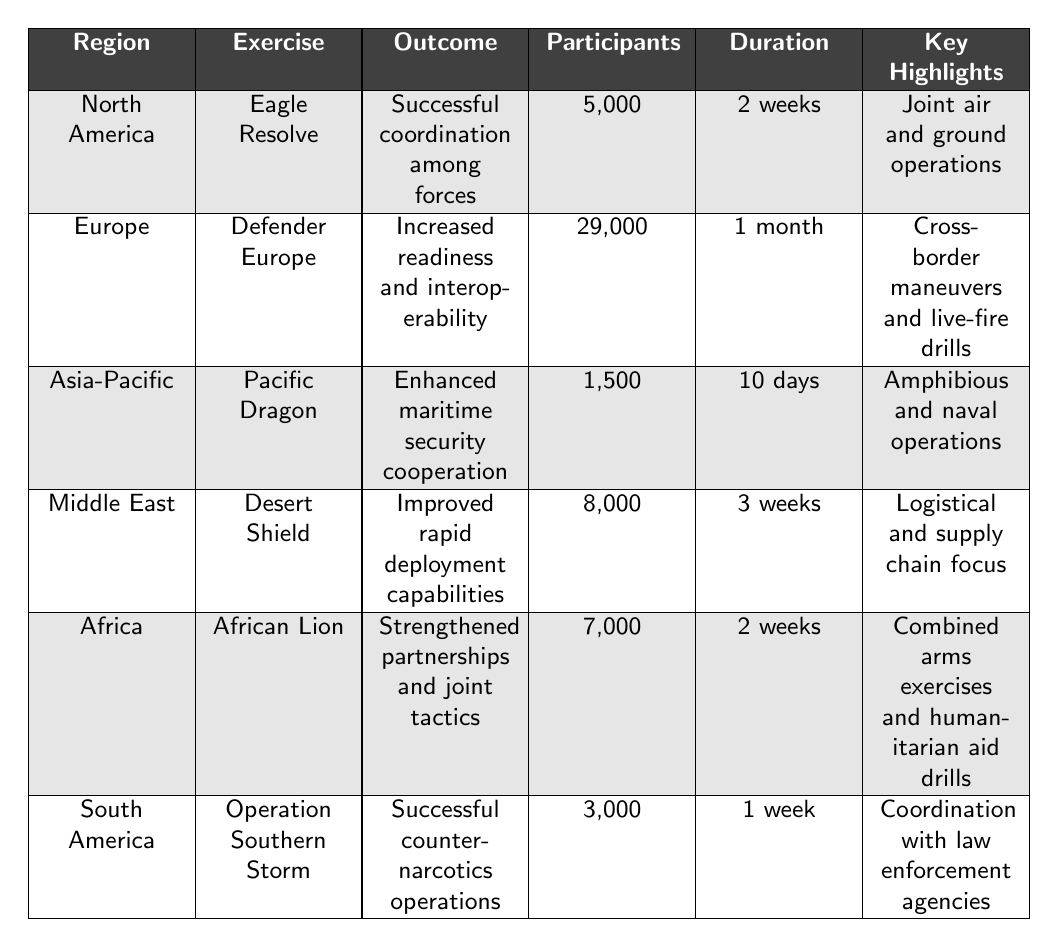What is the region with the highest number of participants in tactical exercises? By examining the 'Participants' column, I see that 'Defender Europe' in Europe has 29,000 participants, which is higher than any other entry.
Answer: Europe Which exercise took place in the Asia-Pacific region? The table lists 'Pacific Dragon' as the exercise under the Asia-Pacific region.
Answer: Pacific Dragon Was there an exercise with more than 10,000 participants? Yes, 'Defender Europe' had 29,000 participants, which is greater than 10,000.
Answer: Yes What is the average duration of the exercises listed? The durations are 2 weeks, 1 month (4 weeks), 10 days (approximately 1.43 weeks), 3 weeks, 2 weeks, and 1 week. Converting everything to weeks: (2 + 4 + 1.43 + 3 + 2 + 1) = 13.43 weeks total for 6 exercises, so the average is 13.43 / 6 = 2.24 weeks.
Answer: 2.24 weeks What outcome was most common among the exercises listed? The outcomes include 'Successful coordination among forces', 'Increased readiness and interoperability', 'Enhanced maritime security cooperation', 'Improved rapid deployment capabilities', 'Strengthened partnerships and joint tactics', and 'Successful counter-narcotics operations'. Each appears only once, indicating no common outcome.
Answer: No common outcome Which exercise had the shortest duration, and what was that duration? 'Operation Southern Storm' took 1 week, which is shorter than the others.
Answer: Operation Southern Storm, 1 week If we only consider the African and South American exercises, what can be said about their outcomes? The African Lion focused on partnerships and tactics while Operation Southern Storm focused on counter-narcotics operations, indicating different foci.
Answer: Different focuses How many participants were involved in the North American and European exercises combined? 'Eagle Resolve' in North America had 5,000 participants and 'Defender Europe' in Europe had 29,000 participants. Adding these gives 5,000 + 29,000 = 34,000 participants.
Answer: 34,000 participants Was 'Desert Shield' focused on humanitarian aid? No, 'Desert Shield' concentrated on improving rapid deployment capabilities and logistics, rather than humanitarian aid.
Answer: No Which region had the fewest participants in their exercise? 'Pacific Dragon' in the Asia-Pacific region had the fewest participants at 1,500.
Answer: Asia-Pacific 